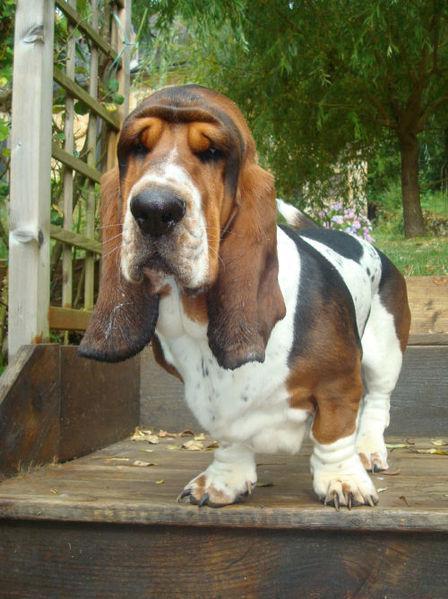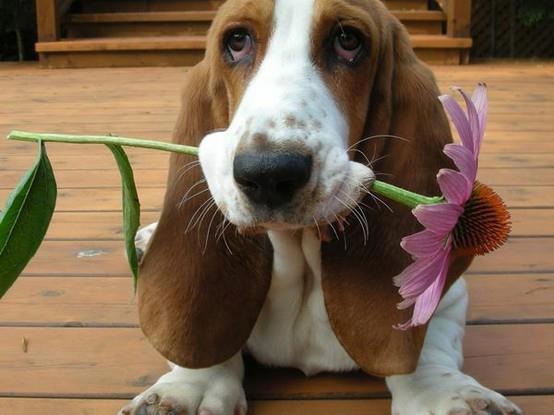The first image is the image on the left, the second image is the image on the right. Given the left and right images, does the statement "bassett hounds are facing the camera" hold true? Answer yes or no. Yes. The first image is the image on the left, the second image is the image on the right. For the images displayed, is the sentence "There is a single hound outside in the grass in the right image." factually correct? Answer yes or no. No. 